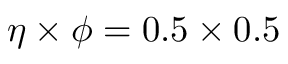<formula> <loc_0><loc_0><loc_500><loc_500>\eta \times \phi = 0 . 5 \times 0 . 5</formula> 